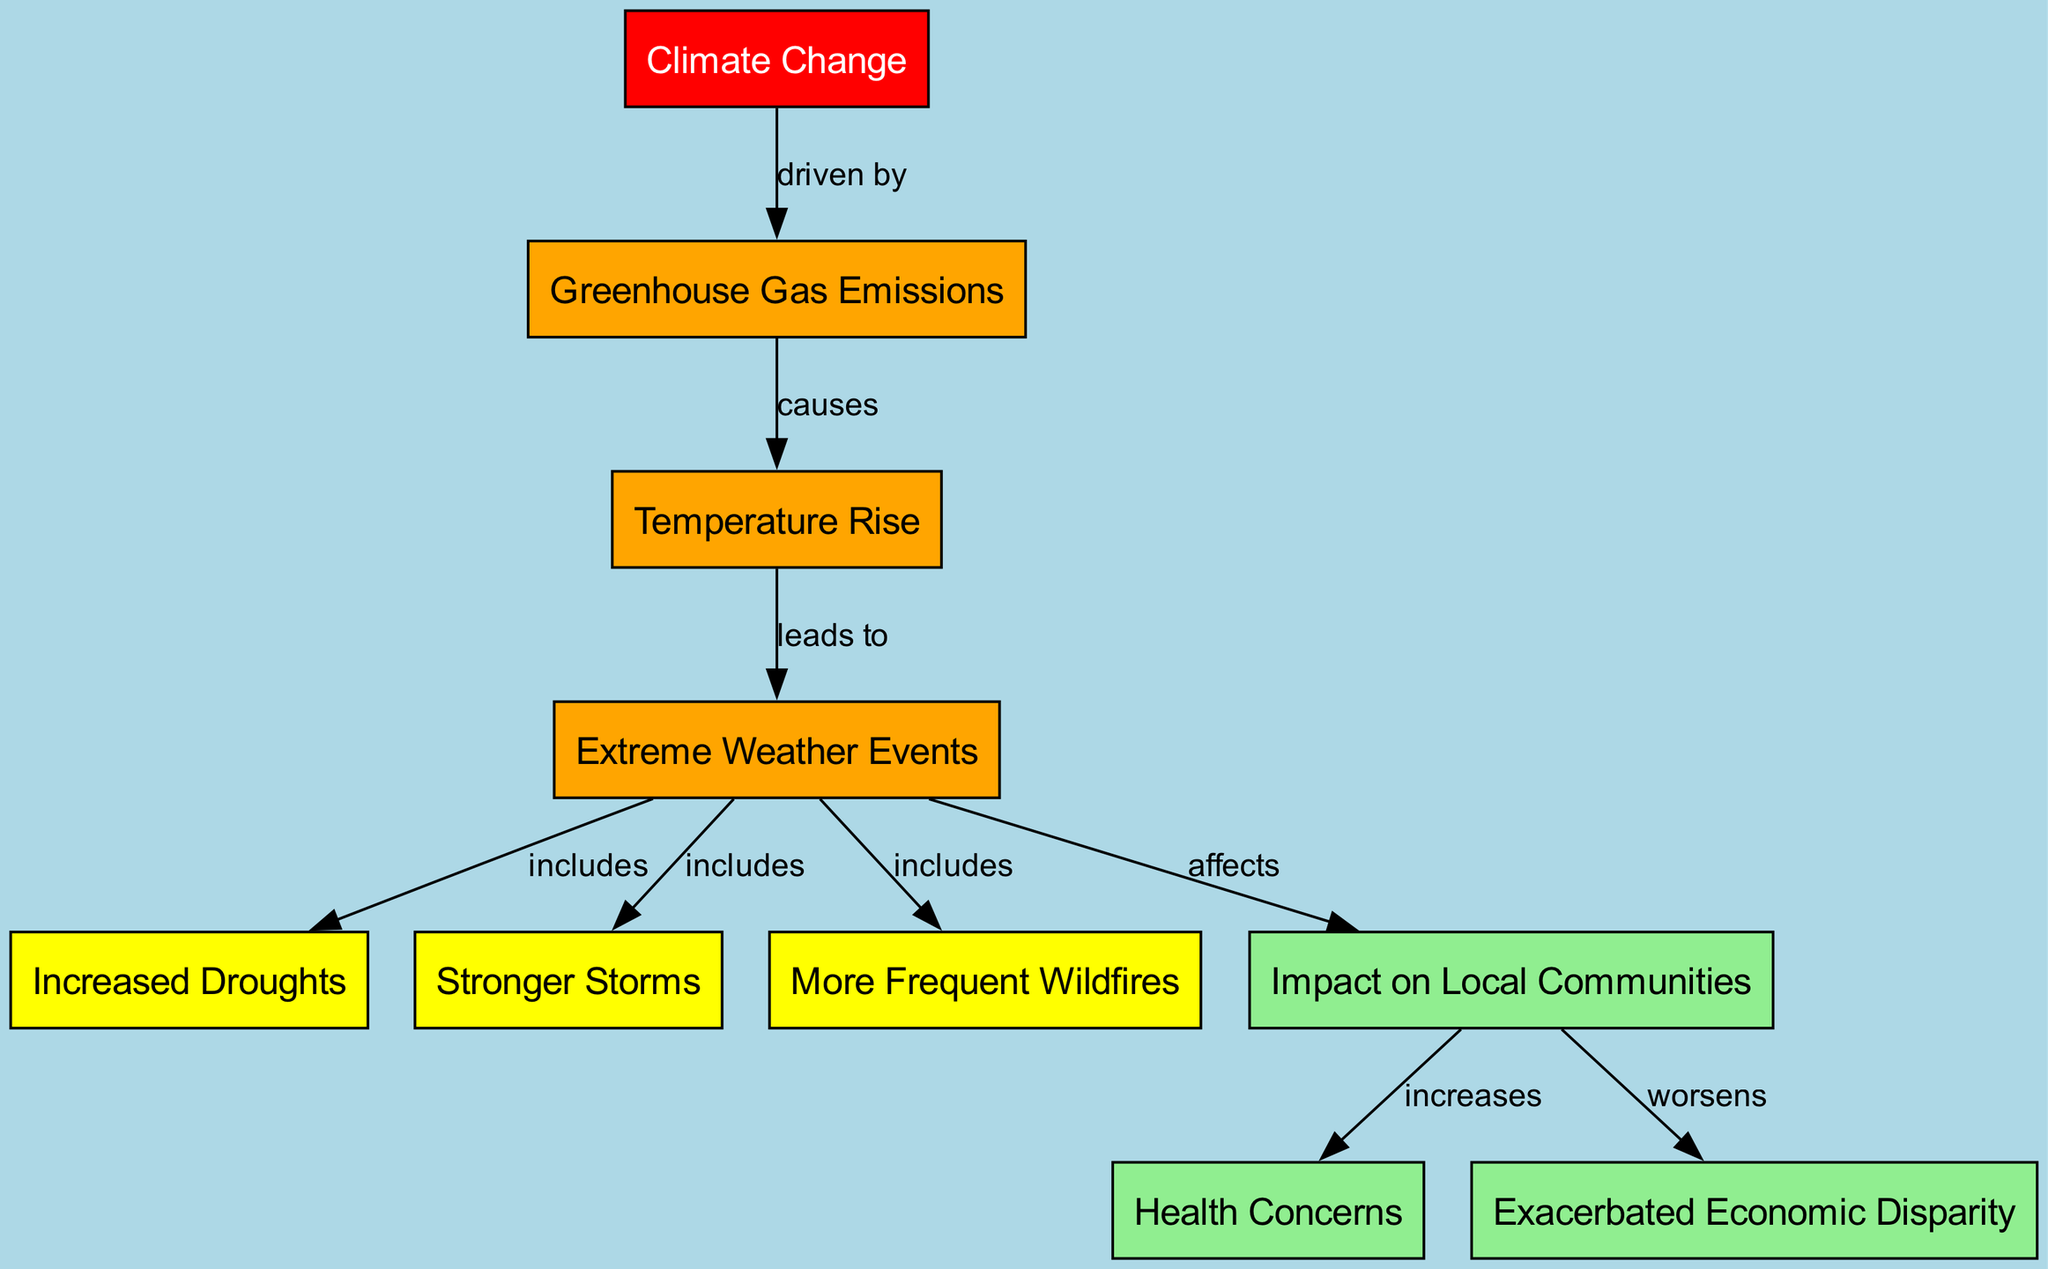What is the first node in the diagram? The first node in the diagram is labeled "Climate Change," which is identified by the "id" key in the nodes list.
Answer: Climate Change How many nodes are present in the diagram? By counting each unique node listed under the "nodes" key, there are a total of 10 nodes in the diagram.
Answer: 10 What type of events does "Extreme Weather" include? The "Extreme Weather" node includes three specific types of events: "Droughts," "Storms," and "Wildfires," as indicated by the edges leading from "Extreme Weather" to these nodes.
Answer: Droughts, Storms, Wildfires What effect does "Climate Change" have on "Greenhouse Gas Emissions"? The diagram indicates that "Climate Change" drives "Greenhouse Gas Emissions," as shown by the directed edge labeled "driven by" from "Climate Change" to "Greenhouse Gas Emissions."
Answer: driven by How do "Local Communities" relate to "Health Concerns"? The diagram shows that "Local Communities" increases "Health Concerns," as indicated by the edge labeled "increases" from "Local Communities" to "Health Concerns."
Answer: increases What are the consequences of "Extreme Weather" on local populations? The "Extreme Weather" node affects "Local Communities," which, as indicated by subsequent edges, increases health concerns and worsens economic disparity. This demonstrates the broader impact of extreme weather on local communities.
Answer: affects Which node is worsened by "Local Communities"? The diagram shows that "Local Communities" worsens "Economic Disparity," with a directed edge specifically labeled "worsens."
Answer: Economic Disparity What flows from "Temperature Rise"? The "Temperature Rise" leads to "Extreme Weather," as denoted by the directed edge labeled "leads to," showing the progression from increased temperatures to extreme weather events.
Answer: Extreme Weather What color is the node labeled "Health Concerns"? The "Health Concerns" node is colored light green in the diagram, representing its classification and association within the context of the visual representation.
Answer: light green 